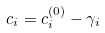<formula> <loc_0><loc_0><loc_500><loc_500>c _ { i } = c ^ { ( 0 ) } _ { i } - \gamma _ { i }</formula> 